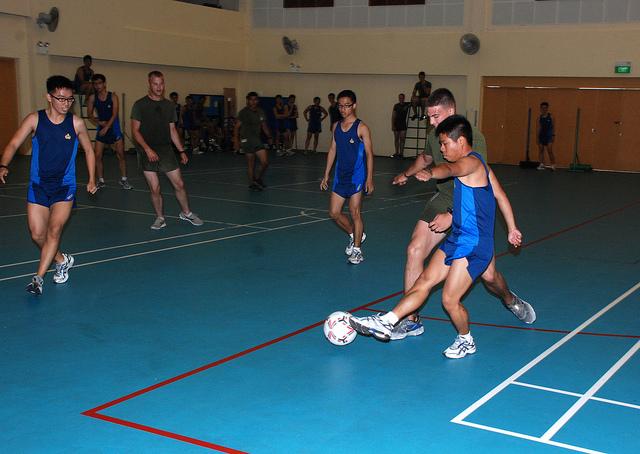What sport is being played?
Short answer required. Soccer. What sport are they playing?
Be succinct. Soccer. Which sport is this?
Concise answer only. Soccer. Is that a tennis racket?
Concise answer only. No. How many men are playing with the ball?
Write a very short answer. 2. Is this sport being played in a school?
Write a very short answer. Yes. How many people are wearing a blue shirt?
Quick response, please. 3. 